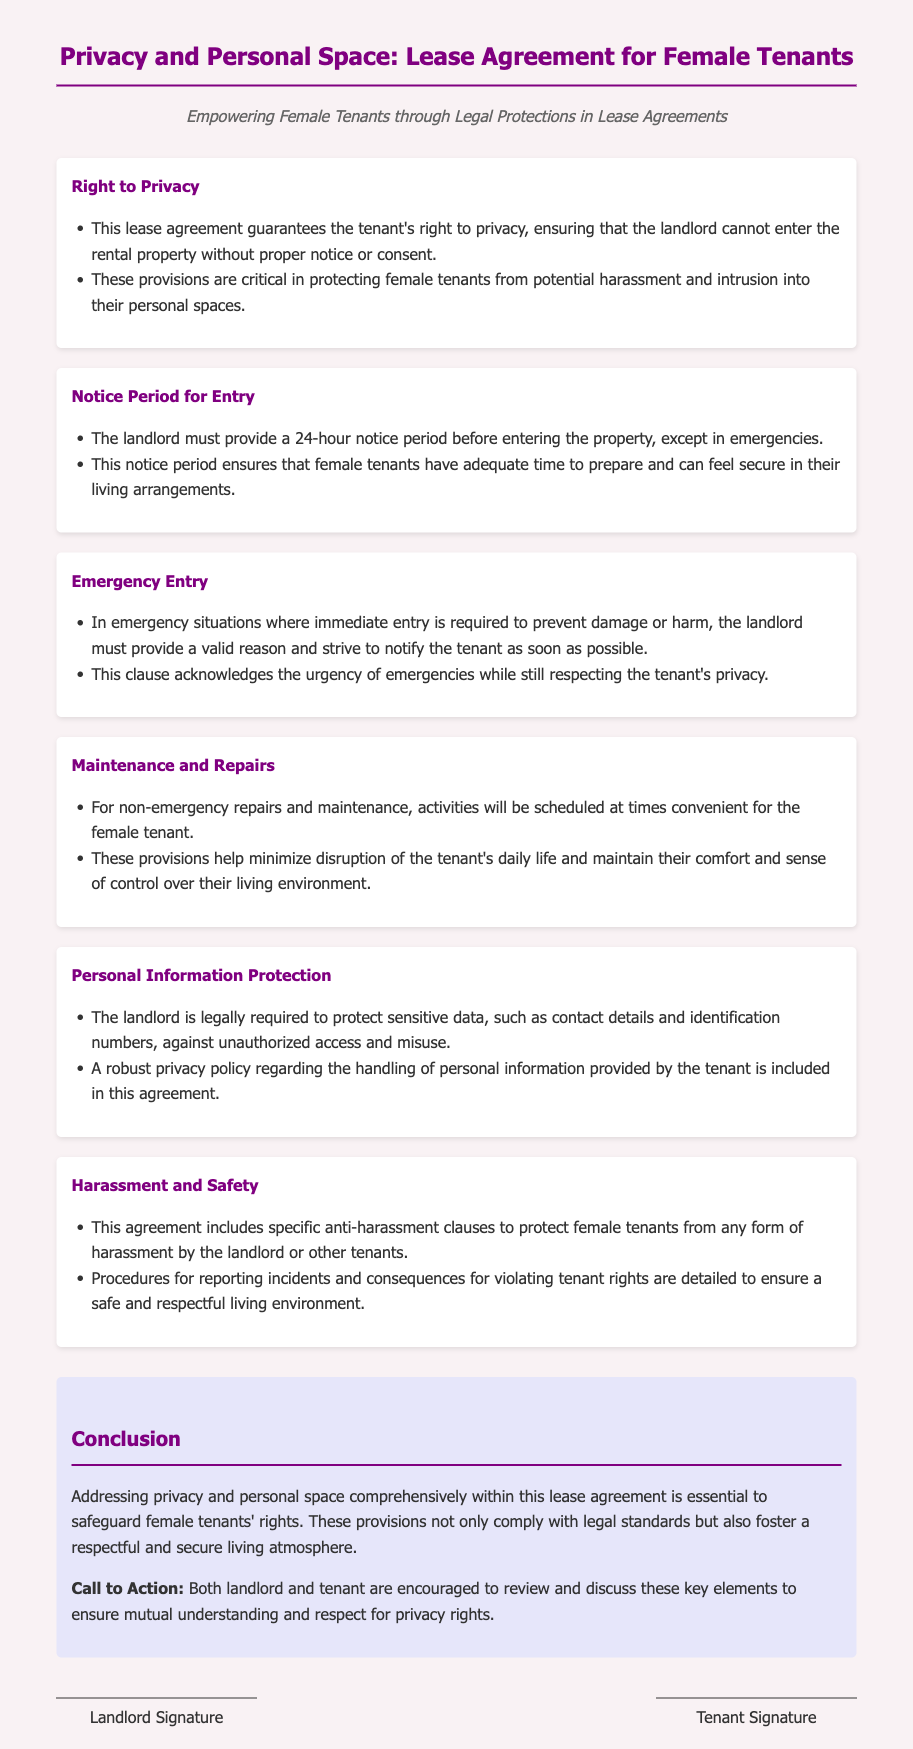what is guaranteed under the Right to Privacy section? The Right to Privacy section guarantees the tenant's right to privacy, ensuring that the landlord cannot enter the rental property without proper notice or consent.
Answer: tenant's right to privacy what is the notice period for entry? The lease agreement states that the landlord must provide a notice period before entering the property, which is 24 hours, except in emergencies.
Answer: 24 hours what must the landlord provide in emergency situations? In emergency situations, the landlord must provide a valid reason and strive to notify the tenant as soon as possible.
Answer: valid reason how are non-emergency repairs scheduled? Non-emergency repairs and maintenance will be scheduled at times convenient for the female tenant to minimize disruption.
Answer: convenient for the female tenant what type of clauses are included to protect female tenants? The agreement includes specific anti-harassment clauses to protect female tenants from any form of harassment by the landlord or other tenants.
Answer: anti-harassment clauses who is responsible for protecting personal information? The landlord is legally required to protect sensitive data against unauthorized access and misuse.
Answer: landlord what should both parties do regarding privacy rights? Both landlord and tenant are encouraged to review and discuss these key elements to ensure mutual understanding and respect for privacy rights.
Answer: review and discuss what is the main purpose of this lease agreement? The main purpose is to safeguard female tenants' rights by addressing privacy and personal space comprehensively.
Answer: safeguard female tenants' rights 